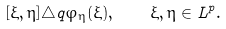<formula> <loc_0><loc_0><loc_500><loc_500>[ \xi , \eta ] \triangle q \varphi _ { \eta } ( \xi ) , \quad \xi , \eta \in L ^ { p } .</formula> 